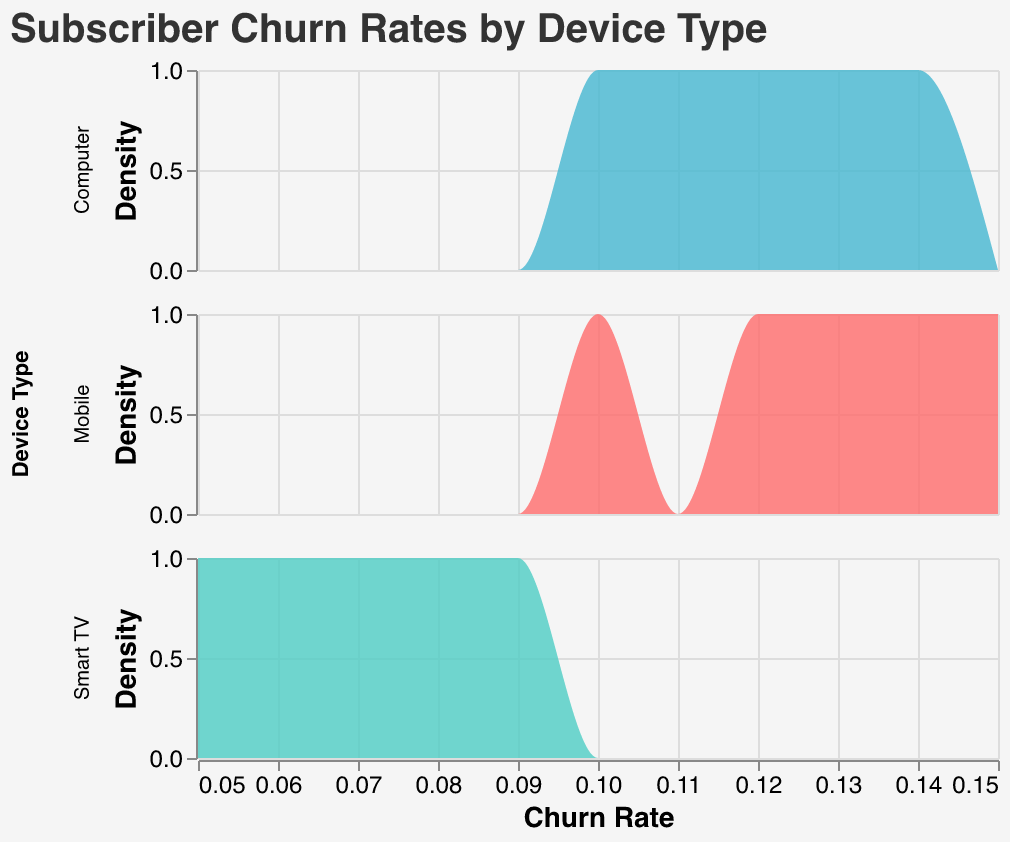What is the title of the plot? The title is displayed at the top of the plot and reads "Subscriber Churn Rates by Device Type".
Answer: Subscriber Churn Rates by Device Type What device type has the lowest churn rate in the given data? The density plot shows the lowest churn rate for each device type along the x-axis. For Smart TV, the lowest churn rate is 0.05, which is the lowest compared to Mobile and Computer.
Answer: Smart TV Which device type tends to have the highest churn rates? By looking at the peaks of the density curves along the x-axis, we can see that Mobile has a density peak at higher churn rate values compared to Smart TV and Computer.
Answer: Mobile How many different device types are shown in the plot? The plot has three separate density plots, one for each device type: Mobile, Smart TV, and Computer.
Answer: 3 What is the color associated with the "Computer" device type? In the legend for the density plots, the color for "Computer" is shown. It is a blue color.
Answer: Blue How do the churn rates for Smart TV compare to those for Computer? By observing the density plots' x-axis positions, Smart TV churn rates are mostly between 0.05 and 0.09, while Computer churn rates are between 0.10 and 0.14.
Answer: Smart TV has lower churn rates than Computer What's the median churn rate for Mobile? Observing the density plot for Mobile, the median churn rate appears around the middle value of the dataset, which is between 0.12 and 0.13.
Answer: 0.12-0.13 How are the titles and labels styled in the density plot? The title text for the plot is stylized with a size of 20 and uses the Helvetica font in color #333333. Axis labels have font sizes of 14 for titles and 12 for labels.
Answer: Styled with Helvetica Which device type shows the highest density at a specific churn rate? By examining the peak of each density curve, Smart TV shows the highest density at a churn rate between 0.06 and 0.07, reaching the highest peak.
Answer: Smart TV 